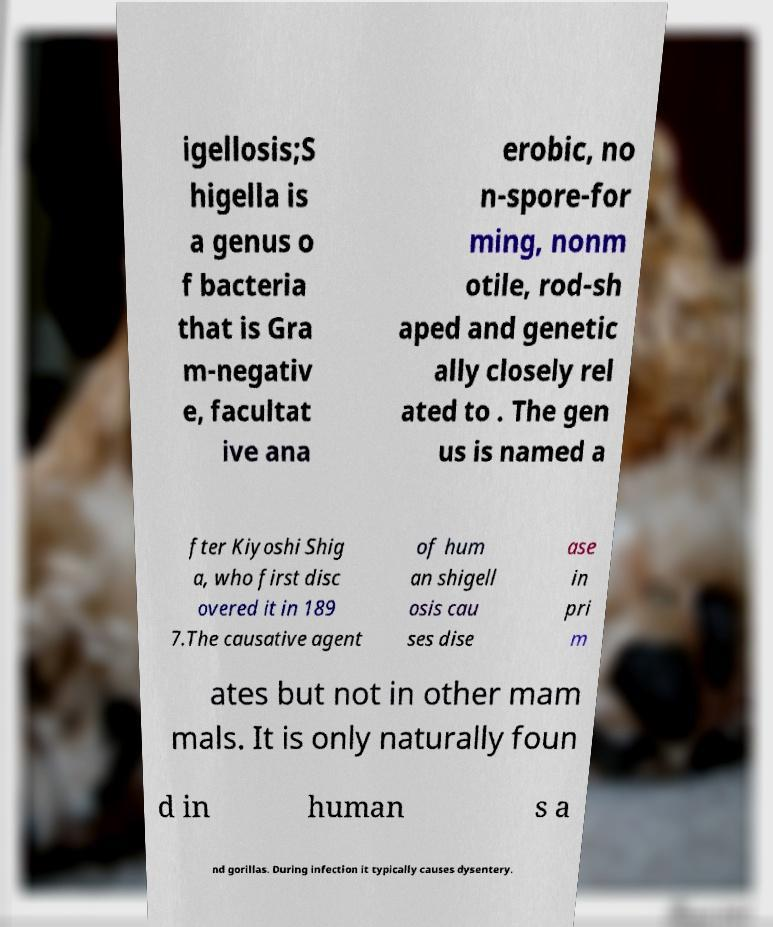Can you read and provide the text displayed in the image?This photo seems to have some interesting text. Can you extract and type it out for me? igellosis;S higella is a genus o f bacteria that is Gra m-negativ e, facultat ive ana erobic, no n-spore-for ming, nonm otile, rod-sh aped and genetic ally closely rel ated to . The gen us is named a fter Kiyoshi Shig a, who first disc overed it in 189 7.The causative agent of hum an shigell osis cau ses dise ase in pri m ates but not in other mam mals. It is only naturally foun d in human s a nd gorillas. During infection it typically causes dysentery. 